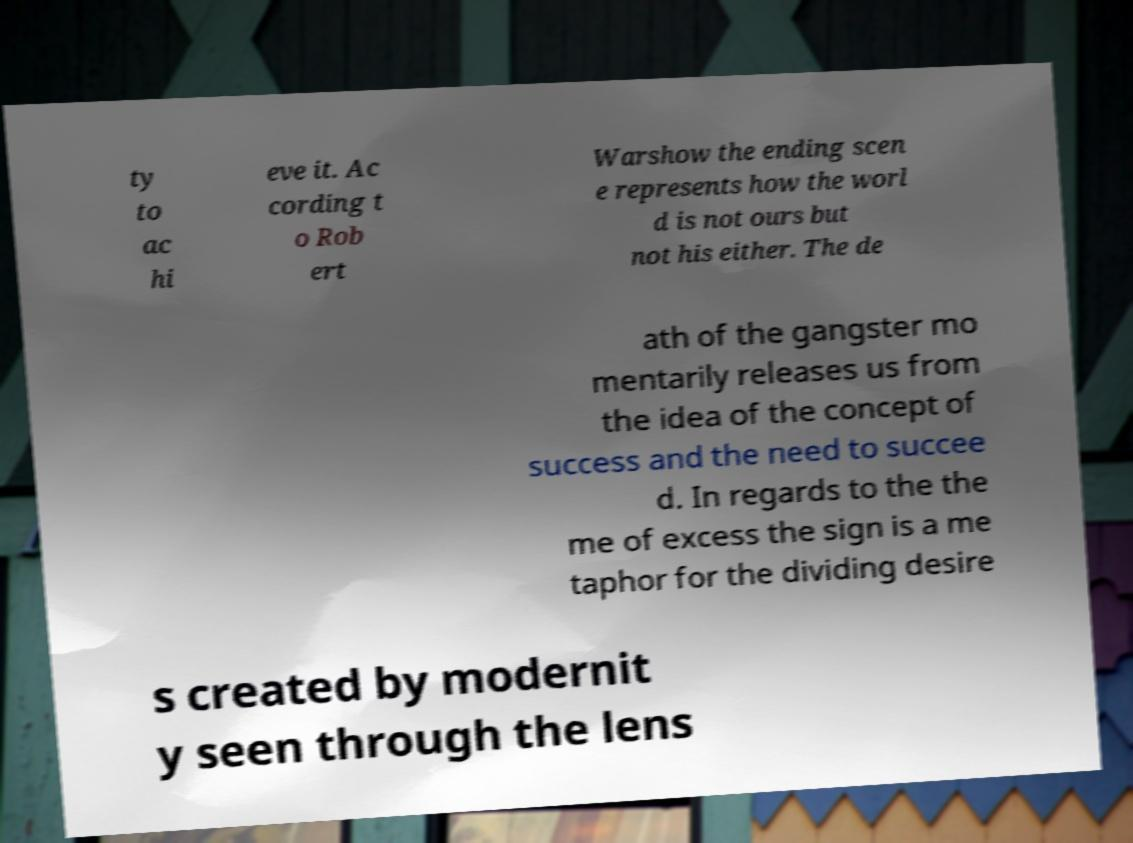Could you extract and type out the text from this image? ty to ac hi eve it. Ac cording t o Rob ert Warshow the ending scen e represents how the worl d is not ours but not his either. The de ath of the gangster mo mentarily releases us from the idea of the concept of success and the need to succee d. In regards to the the me of excess the sign is a me taphor for the dividing desire s created by modernit y seen through the lens 